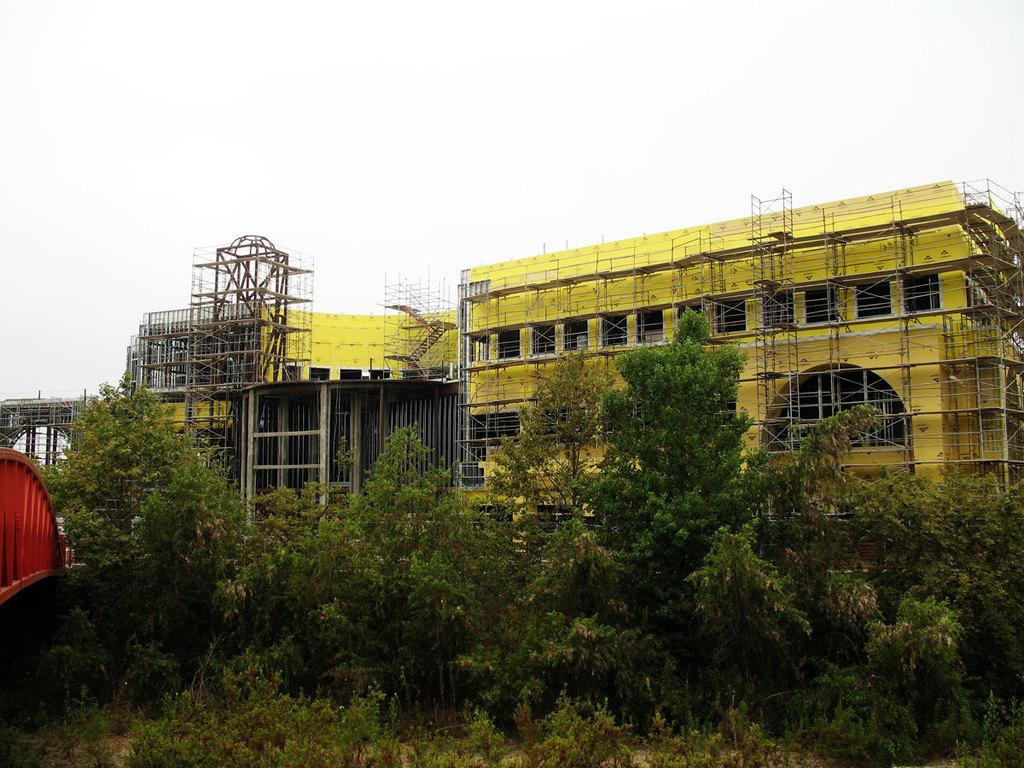What type of structure is present in the image? There is a building in the image. What is the color of the building? The building is yellow in color. What can be seen in front of the building? There are trees in front of the building. Can you see any bursts of clams in the image? There are no bursts of clams present in the image. 